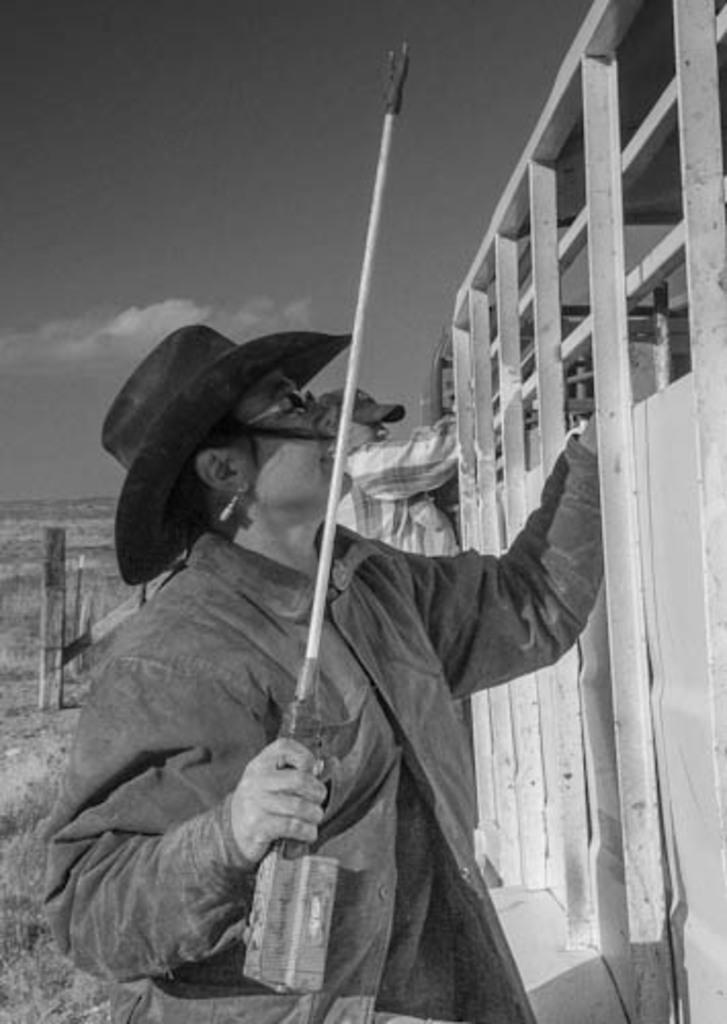What are the people in the image doing? The people in the image are standing on the ground and holding a stick. What is in front of the people? There is a fence in front of the people. What can be seen at the top of the image? The sky is visible at the top of the image. What type of jam is being spread on the neck of the cattle in the image? There is no cattle or jam present in the image. What type of neck is visible in the image? There is no neck visible in the image; the focus is on the people holding a stick and standing in front of a fence. 